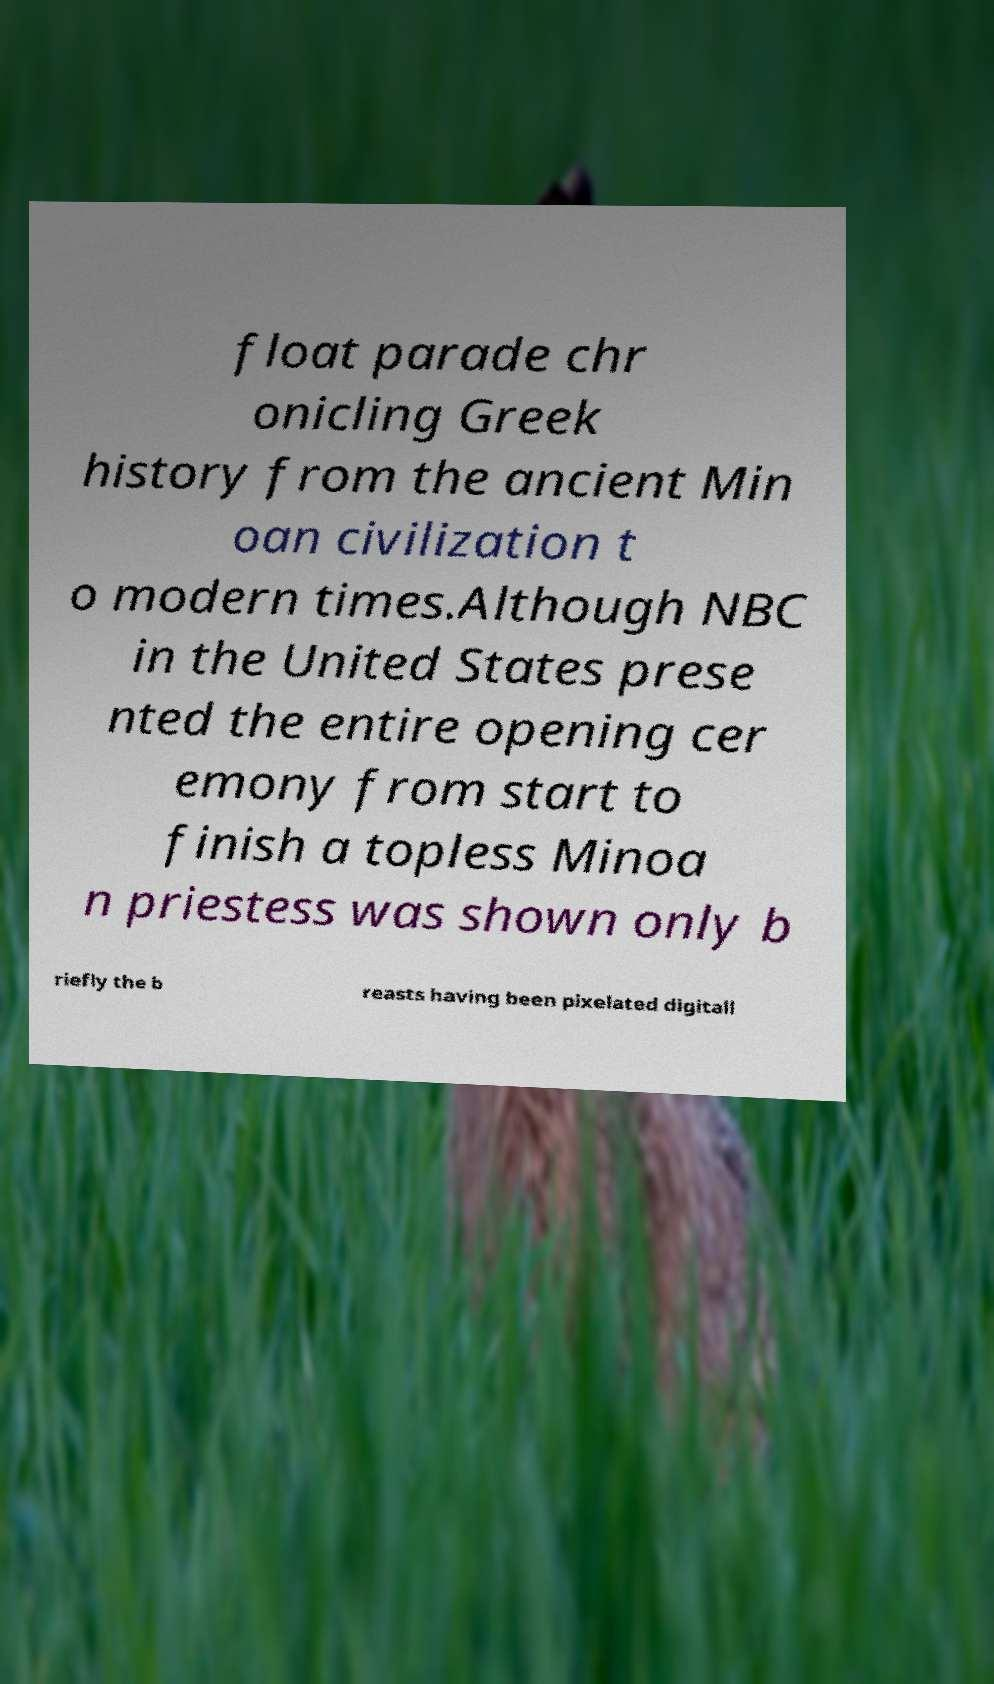Can you read and provide the text displayed in the image?This photo seems to have some interesting text. Can you extract and type it out for me? float parade chr onicling Greek history from the ancient Min oan civilization t o modern times.Although NBC in the United States prese nted the entire opening cer emony from start to finish a topless Minoa n priestess was shown only b riefly the b reasts having been pixelated digitall 